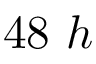<formula> <loc_0><loc_0><loc_500><loc_500>4 8 \ h</formula> 